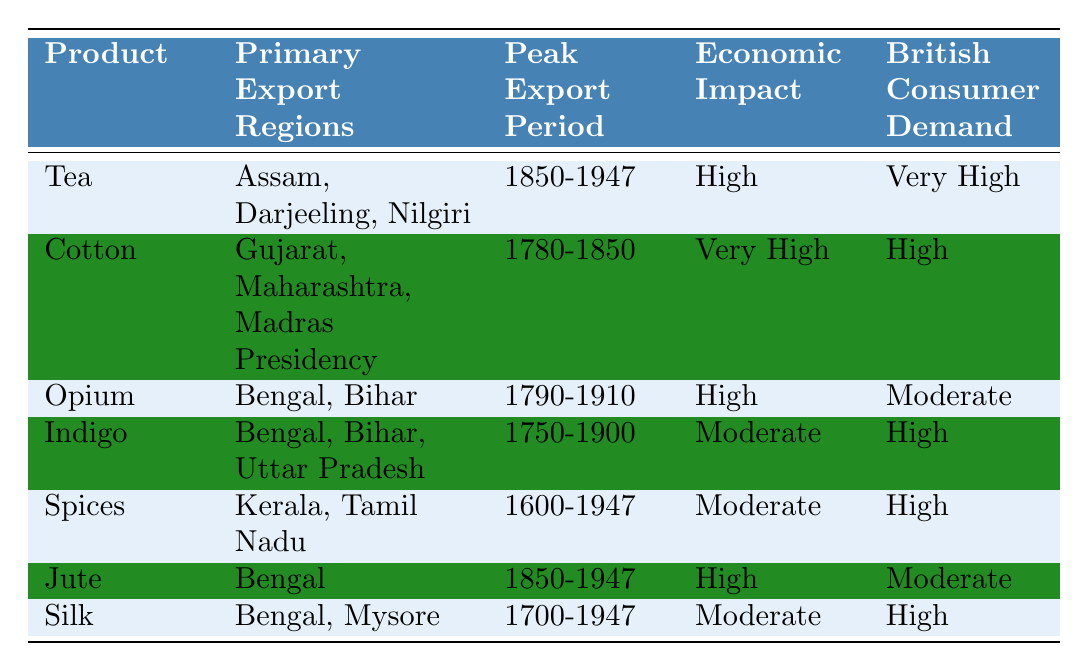What are the primary export regions for Tea? From the table, the primary export regions for Tea are listed as Assam, Darjeeling, and Nilgiri.
Answer: Assam, Darjeeling, Nilgiri During which period was Opium primarily exported? Referring to the table, the peak export period for Opium is indicated as 1790-1910.
Answer: 1790-1910 What was the economic impact of Indigo? The table states that the economic impact of Indigo is categorized as Moderate.
Answer: Moderate Which trade good had very high British consumer demand? Looking at the table, Cotton and Tea both have a designation of Very High for British consumer demand.
Answer: Cotton, Tea Was the economic impact of Silk High? According to the table, the economic impact of Silk is Moderate, not High. Therefore, the answer is No.
Answer: No How many trade goods had a Moderate economic impact? By reviewing the table, the trade goods that have a Moderate economic impact are Indigo, Spices, Silk, and Opium, totaling four goods.
Answer: 4 Which product had the peak export period overlapping the longest with British colonial rule? Inspecting the table, Spices have the longest peak export period from 1600 to 1947, indicating a full span of colonial rule and beyond.
Answer: Spices What is the total number of products listed in the table? There are a total of seven products listed in the table: Tea, Cotton, Opium, Indigo, Spices, Jute, and Silk.
Answer: 7 Which two products have High British consumer demand? Referring to the table, Cotton and Indigo both share the characteristic of High British consumer demand.
Answer: Cotton, Indigo If we compare the economic impact of Jute and Opium, which one is higher? The economic impact for Jute is categorized as High while for Opium it is High as well, thus they are equal.
Answer: Equal 